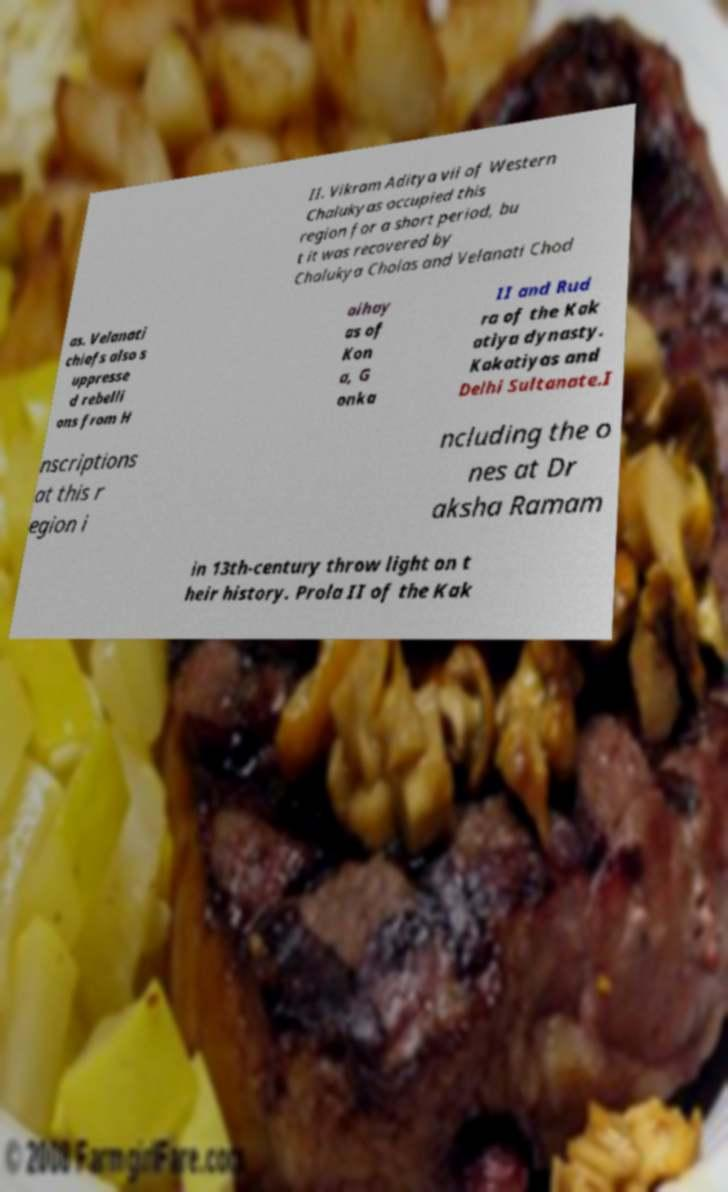Please read and relay the text visible in this image. What does it say? II. Vikram Aditya vii of Western Chalukyas occupied this region for a short period, bu t it was recovered by Chalukya Cholas and Velanati Chod as. Velanati chiefs also s uppresse d rebelli ons from H aihay as of Kon a, G onka II and Rud ra of the Kak atiya dynasty. Kakatiyas and Delhi Sultanate.I nscriptions at this r egion i ncluding the o nes at Dr aksha Ramam in 13th-century throw light on t heir history. Prola II of the Kak 